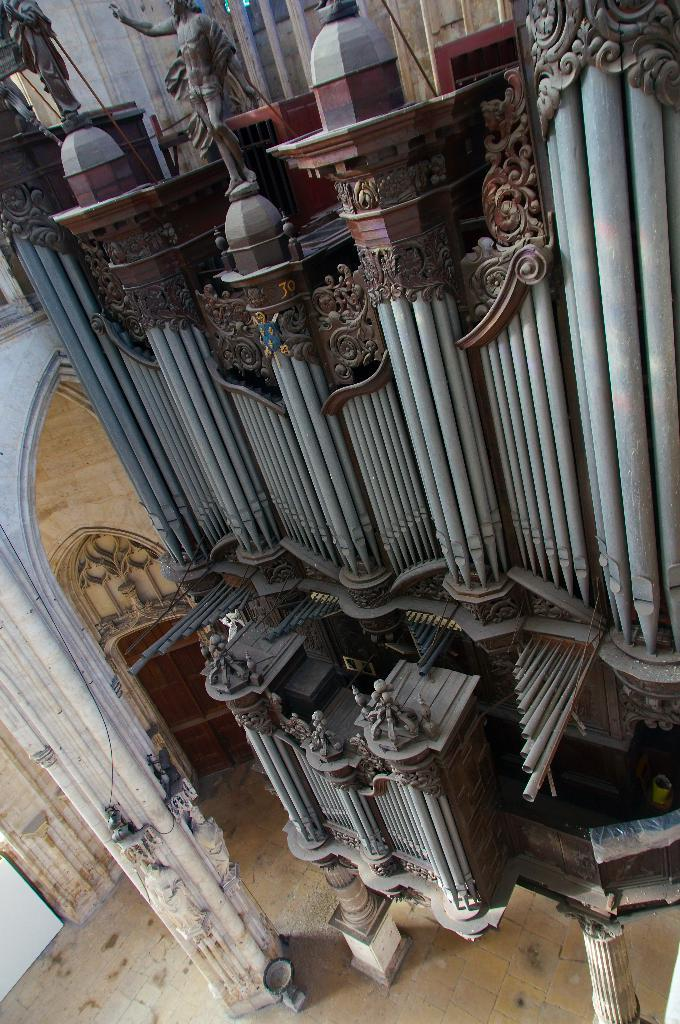What architectural elements can be seen in the image? There are pillars, arches, and doors in the image. What type of artwork is present in the image? There are sculptures and statues in the image. Where are the statues located in the image? The statues are on the top in the image. What type of liquid can be seen flowing from the leg of the statue in the image? There is no liquid flowing from any statue in the image, and there is no mention of a statue with a leg. 